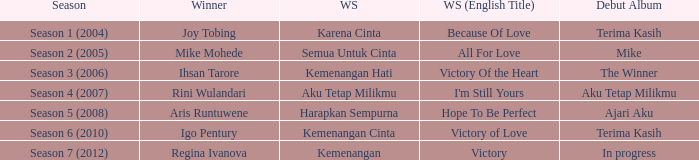Which English winning song had the winner aris runtuwene? Hope To Be Perfect. 